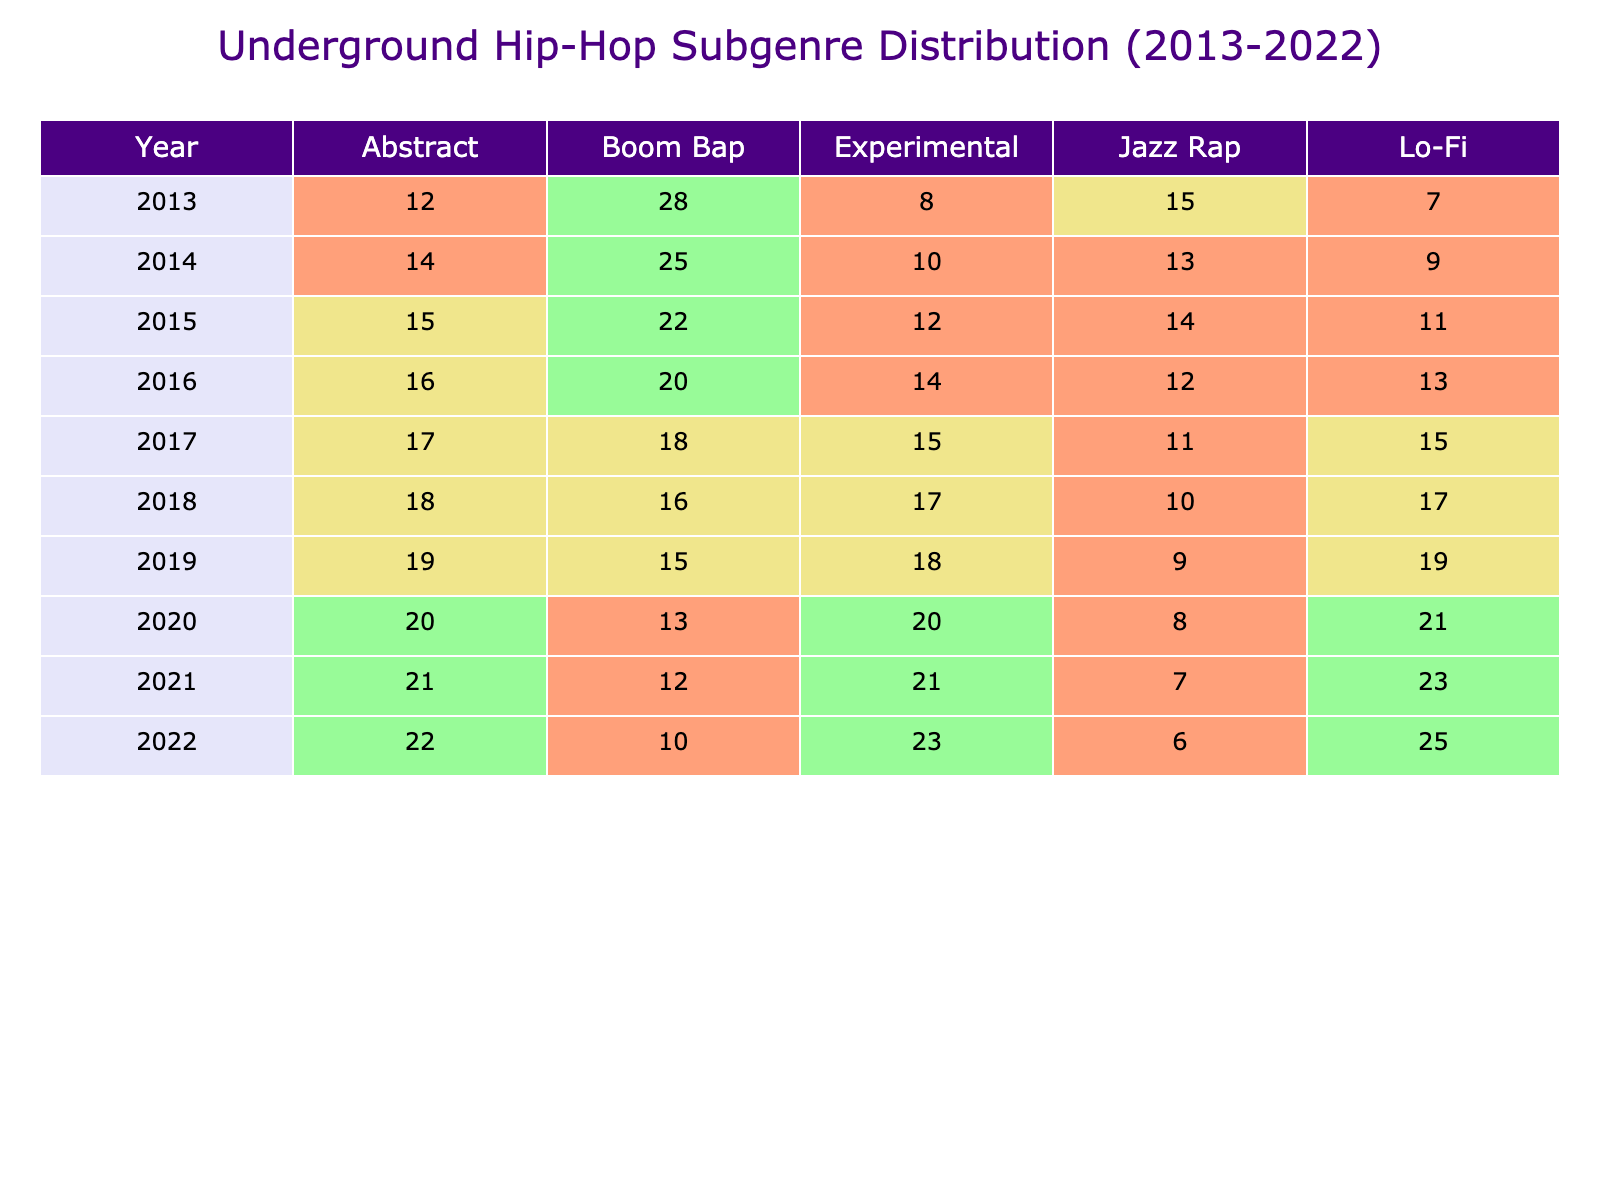What was the percentage of Boom Bap in 2018? Referring to the table, under the year 2018, the percentage listed for the Boom Bap subgenre is 16.
Answer: 16 What subgenre had the highest percentage in 2022? Looking at the year 2022, the subgenre with the highest percentage listed is Lo-Fi at 25.
Answer: 25 Which year saw the lowest percentage of Lo-Fi? Reviewing the data for Lo-Fi, the lowest percentage occurs in 2014, where it is 9.
Answer: 9 What is the average percentage of Abstract from 2013 to 2022? To find the average, sum the percentages of Abstract for each year (12 + 14 + 15 + 16 + 17 + 18 + 19 + 20 + 21 + 22) =  174. This total is then divided by the number of years (10), yielding an average of 17.4.
Answer: 17.4 Did Jazz Rap increase consistently from 2013 to 2022? By examining the Jazz Rap percentages each year, it’s evident that the values do not strictly increase. The values are 15, 13, 14, 12, 11, 10, 9, 8, 7, and 6, showing a declining pattern instead.
Answer: No Which subgenre had the highest total percentage from 2013 to 2022? To determine this, sum the percentages for each subgenre across all years. Boom Bap totals to 25 + 28 + 22 + 20 + 18 + 16 + 15 + 13 + 12 + 10 =  189. Other subgenres can also be summed to compare. The highest total for All subgenres shows Boom Bap has the highest total of 189.
Answer: Boom Bap What percentage of Experimental was released in 2015? By checking the 2015 row, the percentage stated for the Experimental subgenre is 12.
Answer: 12 Which subgenre had the least representation in 2020? In the year 2020, the subgenre with the least representation is Jazz Rap, with a percentage of 8.
Answer: 8 How did the total percentage of Lo-Fi compare to Abstract in 2019? For that year, Lo-Fi is at 19 and Abstract at 19. Their totals match, showing no difference.
Answer: No difference In which year did Abstract see its highest percentage increase compared to the previous year? By looking at the percentages for Abstract, the greatest increase occurs from 2019 to 2020 (19 to 20), which is a rise of 1 percentage point.
Answer: 1 percentage point Which subgenre has shown the most variability in percentages over the years? Variability can be assessed by looking at the ranges of percentages for each subgenre. Abstract ranges from 12 to 22 (10-point difference), while Experimental varies from 8 to 23 (15-point difference) indicating Experimental has shown the most variability.
Answer: Experimental 